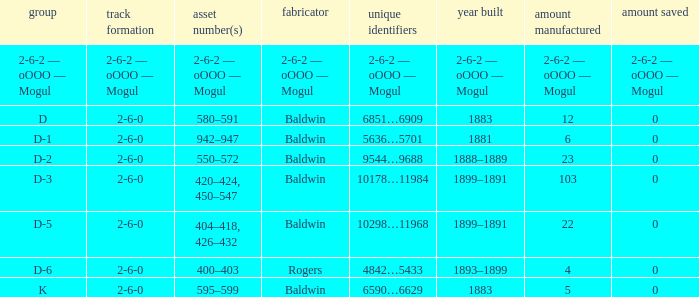What is the class when the quantity perserved is 0 and the quantity made is 5? K. 